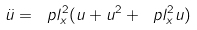Convert formula to latex. <formula><loc_0><loc_0><loc_500><loc_500>\label l { b e . e q } \ddot { u } = \ p l _ { x } ^ { 2 } ( u + u ^ { 2 } + \ p l _ { x } ^ { 2 } u )</formula> 